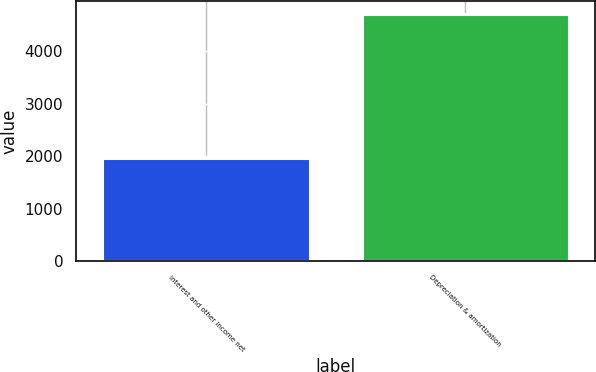Convert chart to OTSL. <chart><loc_0><loc_0><loc_500><loc_500><bar_chart><fcel>Interest and other income net<fcel>Depreciation & amortization<nl><fcel>1961<fcel>4714<nl></chart> 